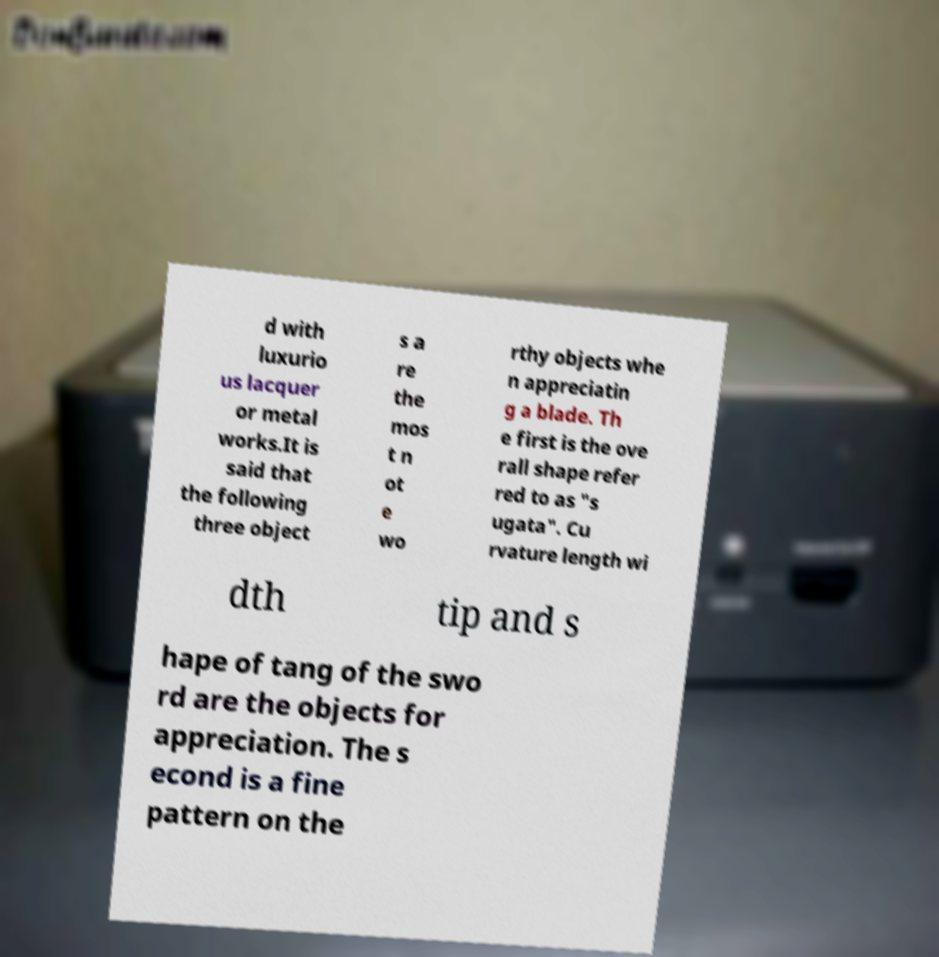Can you accurately transcribe the text from the provided image for me? d with luxurio us lacquer or metal works.It is said that the following three object s a re the mos t n ot e wo rthy objects whe n appreciatin g a blade. Th e first is the ove rall shape refer red to as "s ugata". Cu rvature length wi dth tip and s hape of tang of the swo rd are the objects for appreciation. The s econd is a fine pattern on the 